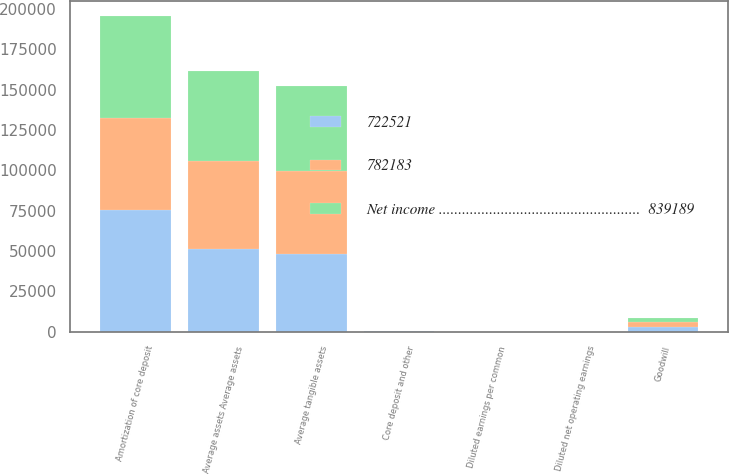Convert chart to OTSL. <chart><loc_0><loc_0><loc_500><loc_500><stacked_bar_chart><ecel><fcel>Amortization of core deposit<fcel>Diluted earnings per common<fcel>Diluted net operating earnings<fcel>Average assets Average assets<fcel>Goodwill<fcel>Core deposit and other<fcel>Average tangible assets<nl><fcel>Net income ....................................................  839189<fcel>63008<fcel>7.37<fcel>7.73<fcel>55839<fcel>2908<fcel>191<fcel>52778<nl><fcel>782183<fcel>56805<fcel>6.73<fcel>7.03<fcel>54135<fcel>2904<fcel>135<fcel>51148<nl><fcel>722521<fcel>75410<fcel>6<fcel>6.38<fcel>51517<fcel>2904<fcel>201<fcel>48412<nl></chart> 